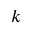<formula> <loc_0><loc_0><loc_500><loc_500>k</formula> 